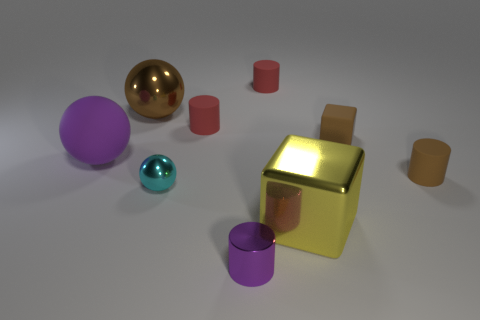Is there any other thing that is the same color as the small sphere?
Make the answer very short. No. There is a cylinder that is the same material as the cyan ball; what is its size?
Ensure brevity in your answer.  Small. There is a purple object on the left side of the red matte cylinder that is in front of the red cylinder that is right of the tiny purple cylinder; what is its material?
Provide a succinct answer. Rubber. Are there fewer small objects than objects?
Your response must be concise. Yes. Does the cyan sphere have the same material as the purple sphere?
Your answer should be compact. No. There is a large metallic object that is the same color as the tiny rubber block; what is its shape?
Provide a succinct answer. Sphere. There is a small thing that is on the right side of the tiny rubber cube; does it have the same color as the small block?
Your answer should be very brief. Yes. There is a brown object that is in front of the small block; what number of small brown objects are in front of it?
Ensure brevity in your answer.  0. What color is the other sphere that is the same size as the brown ball?
Provide a short and direct response. Purple. What is the cube in front of the brown rubber cylinder made of?
Your response must be concise. Metal. 